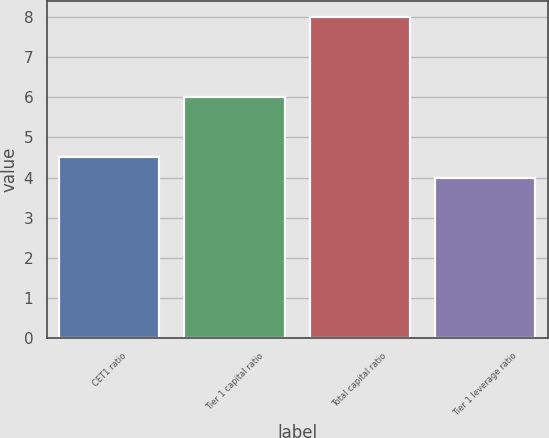Convert chart to OTSL. <chart><loc_0><loc_0><loc_500><loc_500><bar_chart><fcel>CET1 ratio<fcel>Tier 1 capital ratio<fcel>Total capital ratio<fcel>Tier 1 leverage ratio<nl><fcel>4.5<fcel>6<fcel>8<fcel>4<nl></chart> 